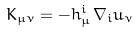<formula> <loc_0><loc_0><loc_500><loc_500>K _ { \mu \nu } = - h _ { \mu } ^ { i } \, \nabla _ { i } u _ { \nu }</formula> 